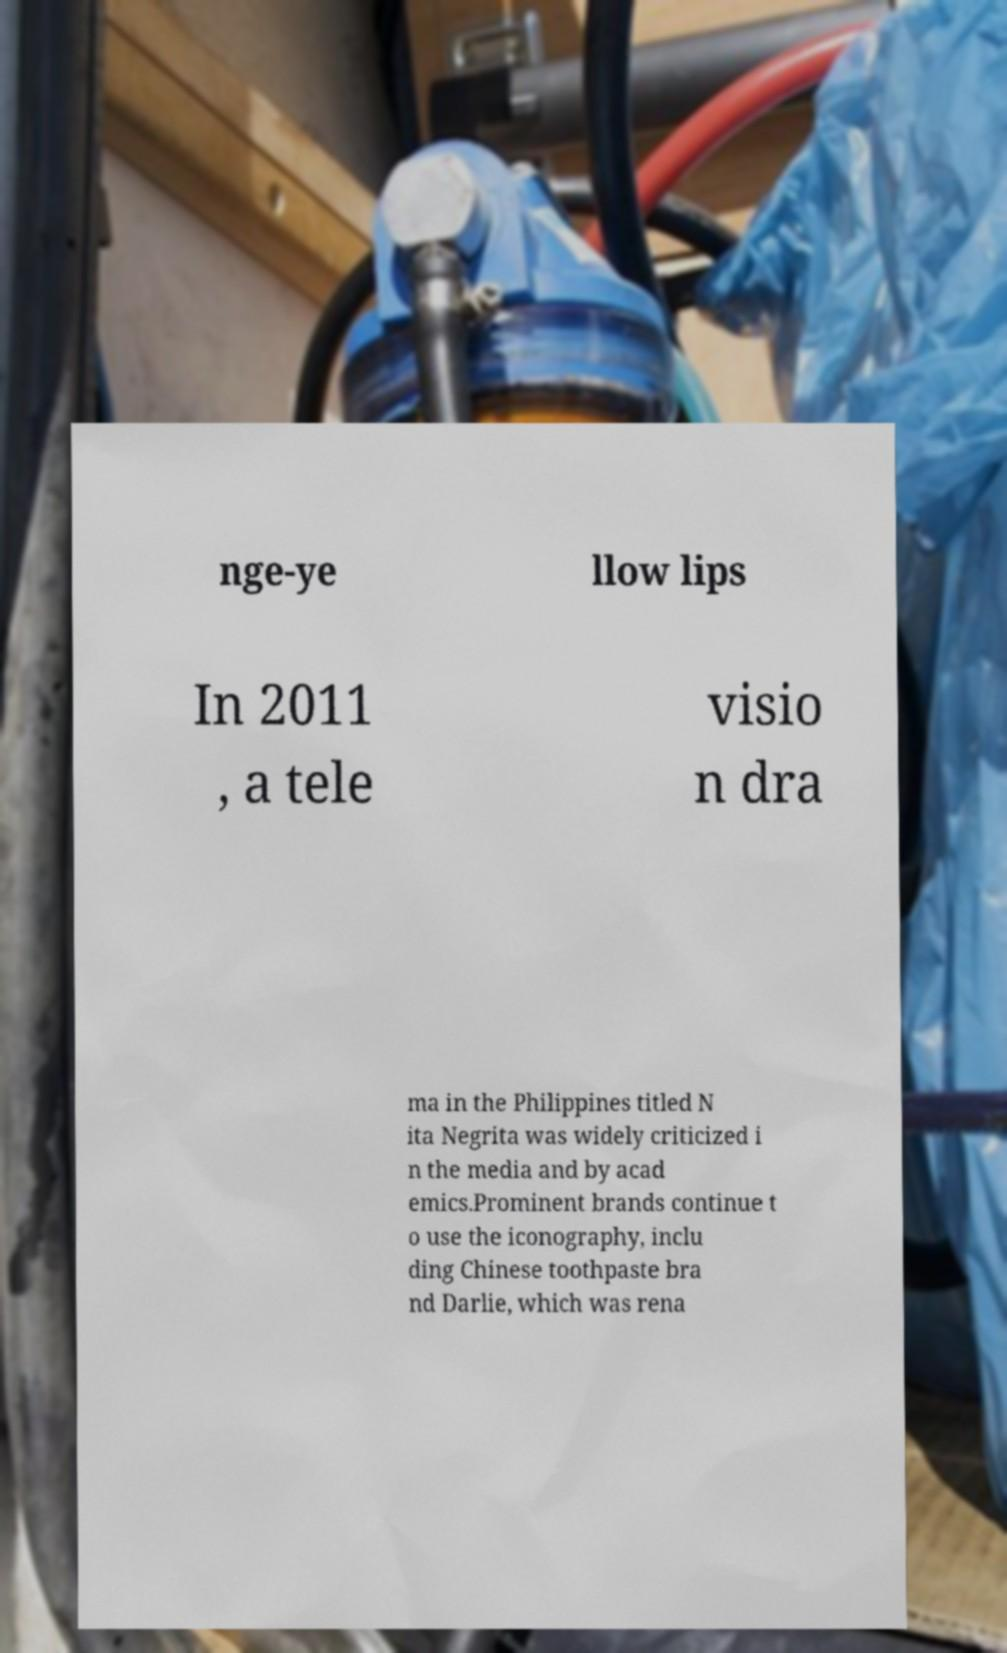What messages or text are displayed in this image? I need them in a readable, typed format. nge-ye llow lips In 2011 , a tele visio n dra ma in the Philippines titled N ita Negrita was widely criticized i n the media and by acad emics.Prominent brands continue t o use the iconography, inclu ding Chinese toothpaste bra nd Darlie, which was rena 